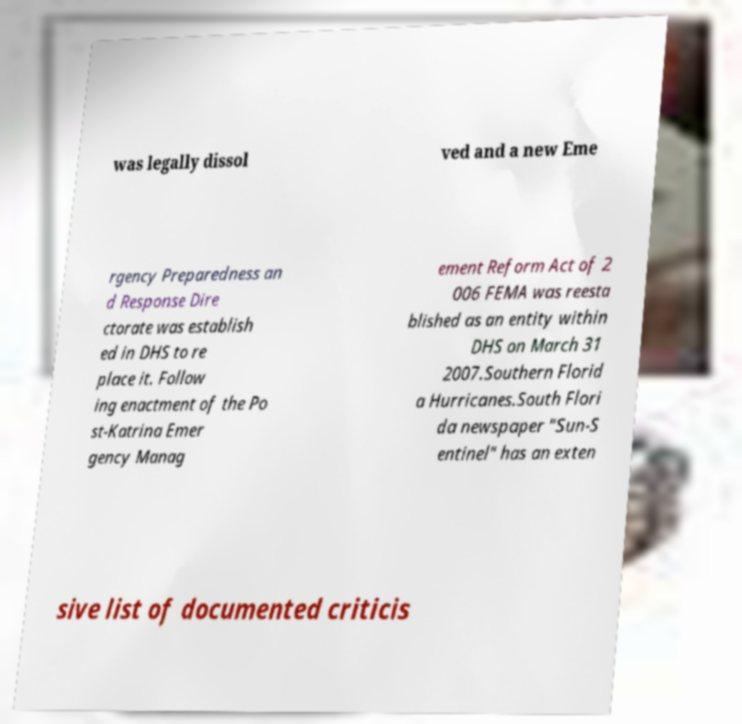For documentation purposes, I need the text within this image transcribed. Could you provide that? was legally dissol ved and a new Eme rgency Preparedness an d Response Dire ctorate was establish ed in DHS to re place it. Follow ing enactment of the Po st-Katrina Emer gency Manag ement Reform Act of 2 006 FEMA was reesta blished as an entity within DHS on March 31 2007.Southern Florid a Hurricanes.South Flori da newspaper "Sun-S entinel" has an exten sive list of documented criticis 